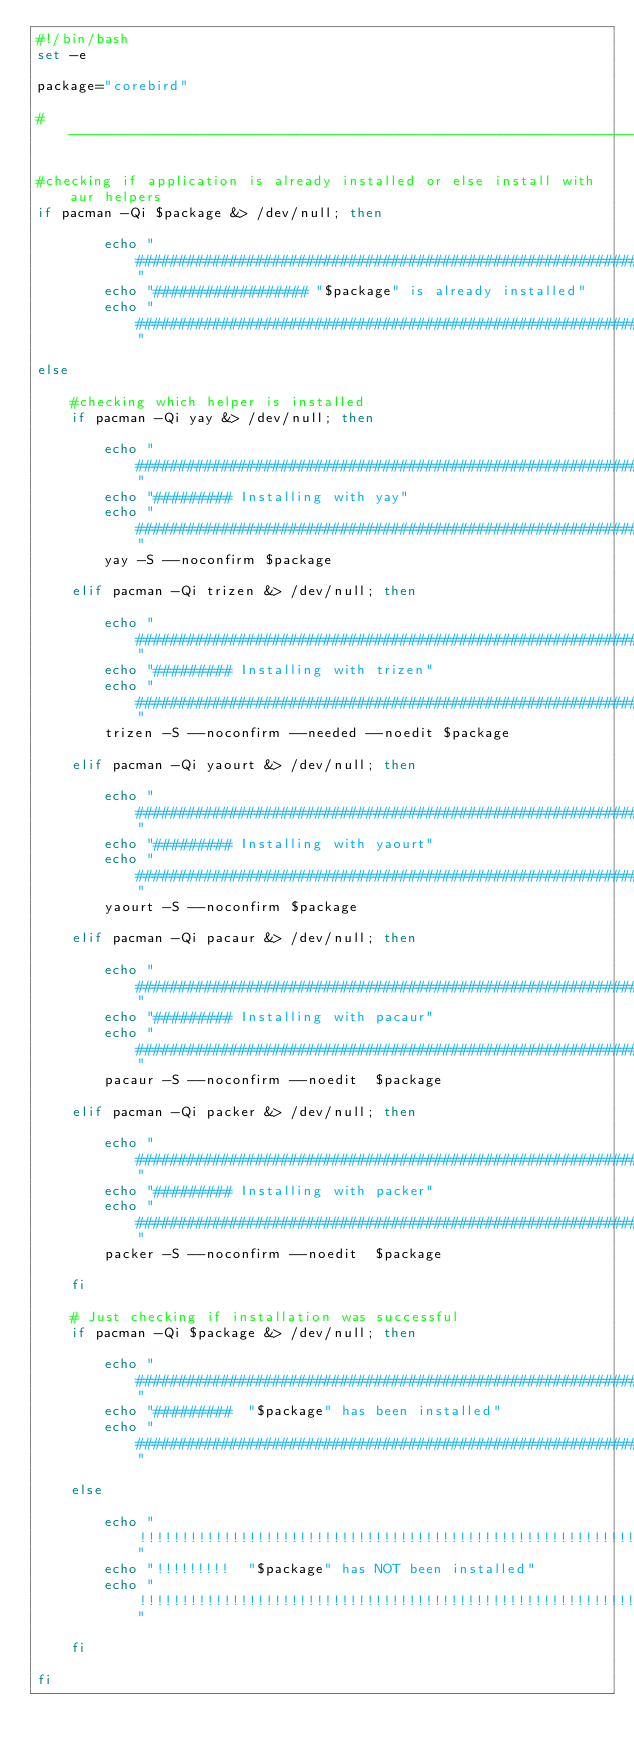Convert code to text. <code><loc_0><loc_0><loc_500><loc_500><_Bash_>#!/bin/bash
set -e

package="corebird"

#----------------------------------------------------------------------------------

#checking if application is already installed or else install with aur helpers
if pacman -Qi $package &> /dev/null; then

		echo "################################################################"
		echo "################## "$package" is already installed"
		echo "################################################################"

else

	#checking which helper is installed
	if pacman -Qi yay &> /dev/null; then

		echo "################################################################"
		echo "######### Installing with yay"
		echo "################################################################"
		yay -S --noconfirm $package

	elif pacman -Qi trizen &> /dev/null; then

		echo "################################################################"
		echo "######### Installing with trizen"
		echo "################################################################"
		trizen -S --noconfirm --needed --noedit $package

	elif pacman -Qi yaourt &> /dev/null; then

		echo "################################################################"
		echo "######### Installing with yaourt"
		echo "################################################################"
		yaourt -S --noconfirm $package

	elif pacman -Qi pacaur &> /dev/null; then

		echo "################################################################"
		echo "######### Installing with pacaur"
		echo "################################################################"
		pacaur -S --noconfirm --noedit  $package

	elif pacman -Qi packer &> /dev/null; then

		echo "################################################################"
		echo "######### Installing with packer"
		echo "################################################################"
		packer -S --noconfirm --noedit  $package

	fi

	# Just checking if installation was successful
	if pacman -Qi $package &> /dev/null; then

		echo "################################################################"
		echo "#########  "$package" has been installed"
		echo "################################################################"

	else

		echo "!!!!!!!!!!!!!!!!!!!!!!!!!!!!!!!!!!!!!!!!!!!!!!!!!!!!!!!!!!!!!!!!"
		echo "!!!!!!!!!  "$package" has NOT been installed"
		echo "!!!!!!!!!!!!!!!!!!!!!!!!!!!!!!!!!!!!!!!!!!!!!!!!!!!!!!!!!!!!!!!!"

	fi

fi
</code> 